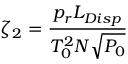<formula> <loc_0><loc_0><loc_500><loc_500>\zeta _ { 2 } = \frac { p _ { r } L _ { D i s p } } { T _ { 0 } ^ { 2 } N \sqrt { P _ { 0 } } }</formula> 